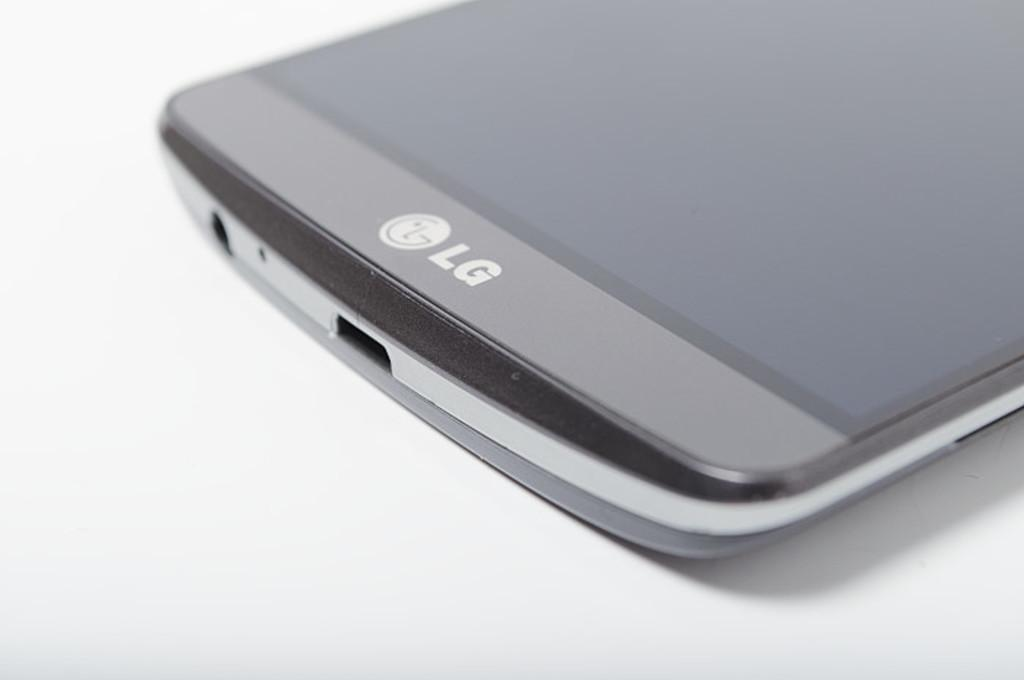<image>
Describe the image concisely. The edge of an LG smartphone with the USB port shown 